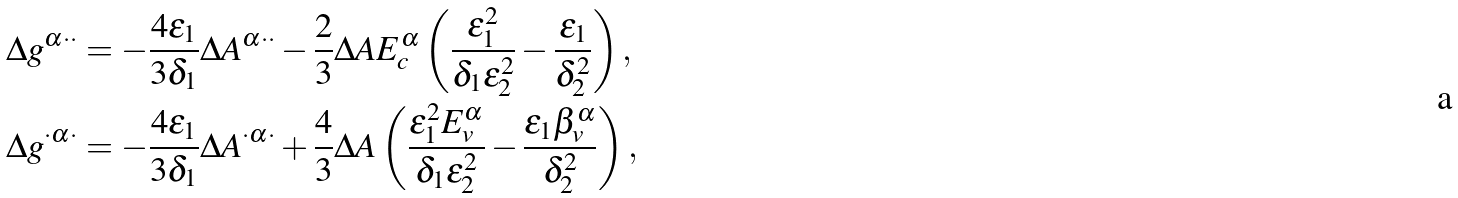<formula> <loc_0><loc_0><loc_500><loc_500>\Delta g ^ { \alpha \cdot \cdot } & = - \frac { 4 \epsilon _ { 1 } } { 3 \delta _ { 1 } } \Delta A ^ { \alpha \cdot \cdot } - \frac { 2 } { 3 } \Delta A E _ { c } ^ { \alpha } \left ( \frac { \epsilon _ { 1 } ^ { 2 } } { \delta _ { 1 } \epsilon _ { 2 } ^ { 2 } } - \frac { \epsilon _ { 1 } } { \delta _ { 2 } ^ { 2 } } \right ) , \\ \Delta g ^ { \cdot \alpha \cdot } & = - \frac { 4 \epsilon _ { 1 } } { 3 \delta _ { 1 } } \Delta A ^ { \cdot \alpha \cdot } + \frac { 4 } { 3 } \Delta A \left ( \frac { \epsilon _ { 1 } ^ { 2 } E _ { v } ^ { \alpha } } { \delta _ { 1 } \epsilon _ { 2 } ^ { 2 } } - \frac { \epsilon _ { 1 } \beta _ { v } ^ { \alpha } } { \delta _ { 2 } ^ { 2 } } \right ) ,</formula> 